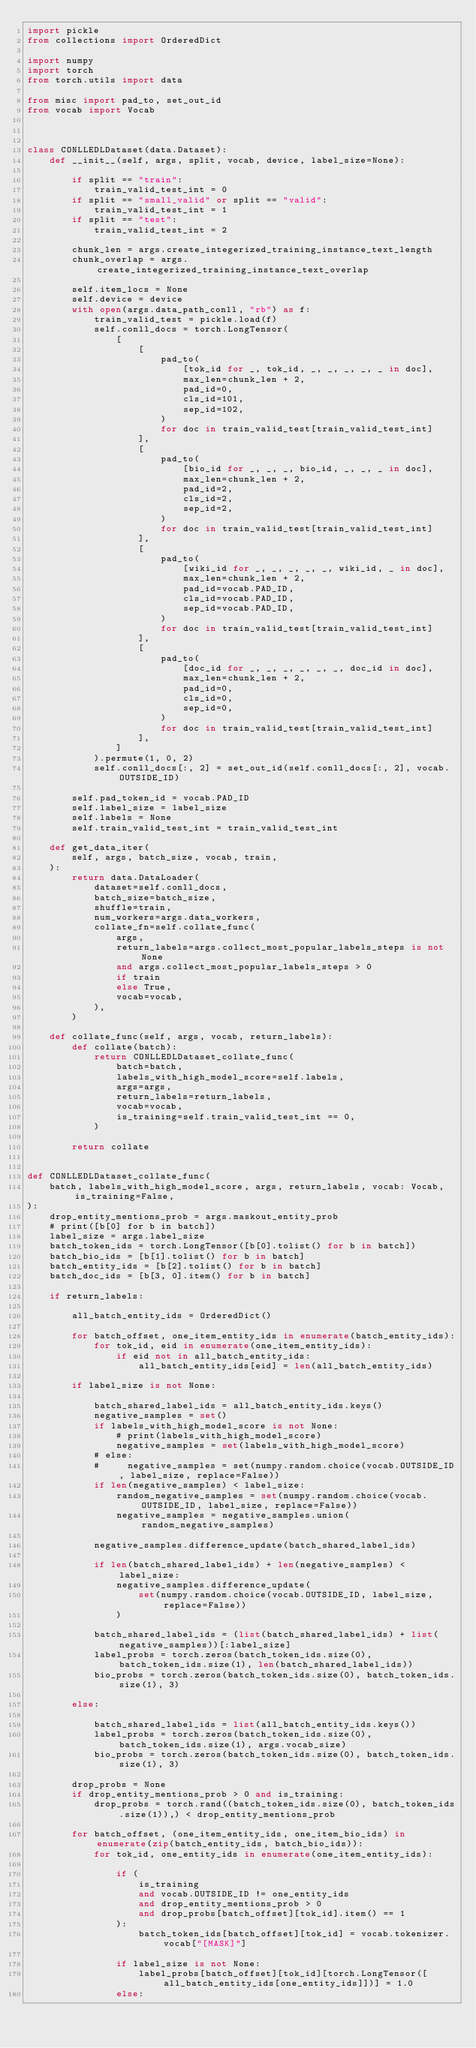<code> <loc_0><loc_0><loc_500><loc_500><_Python_>import pickle
from collections import OrderedDict

import numpy
import torch
from torch.utils import data

from misc import pad_to, set_out_id
from vocab import Vocab



class CONLLEDLDataset(data.Dataset):
    def __init__(self, args, split, vocab, device, label_size=None):

        if split == "train":
            train_valid_test_int = 0
        if split == "small_valid" or split == "valid":
            train_valid_test_int = 1
        if split == "test":
            train_valid_test_int = 2

        chunk_len = args.create_integerized_training_instance_text_length
        chunk_overlap = args.create_integerized_training_instance_text_overlap

        self.item_locs = None
        self.device = device
        with open(args.data_path_conll, "rb") as f:
            train_valid_test = pickle.load(f)
            self.conll_docs = torch.LongTensor(
                [
                    [
                        pad_to(
                            [tok_id for _, tok_id, _, _, _, _, _ in doc],
                            max_len=chunk_len + 2,
                            pad_id=0,
                            cls_id=101,
                            sep_id=102,
                        )
                        for doc in train_valid_test[train_valid_test_int]
                    ],
                    [
                        pad_to(
                            [bio_id for _, _, _, bio_id, _, _, _ in doc],
                            max_len=chunk_len + 2,
                            pad_id=2,
                            cls_id=2,
                            sep_id=2,
                        )
                        for doc in train_valid_test[train_valid_test_int]
                    ],
                    [
                        pad_to(
                            [wiki_id for _, _, _, _, _, wiki_id, _ in doc],
                            max_len=chunk_len + 2,
                            pad_id=vocab.PAD_ID,
                            cls_id=vocab.PAD_ID,
                            sep_id=vocab.PAD_ID,
                        )
                        for doc in train_valid_test[train_valid_test_int]
                    ],
                    [
                        pad_to(
                            [doc_id for _, _, _, _, _, _, doc_id in doc],
                            max_len=chunk_len + 2,
                            pad_id=0,
                            cls_id=0,
                            sep_id=0,
                        )
                        for doc in train_valid_test[train_valid_test_int]
                    ],
                ]
            ).permute(1, 0, 2)
            self.conll_docs[:, 2] = set_out_id(self.conll_docs[:, 2], vocab.OUTSIDE_ID)

        self.pad_token_id = vocab.PAD_ID
        self.label_size = label_size
        self.labels = None
        self.train_valid_test_int = train_valid_test_int

    def get_data_iter(
        self, args, batch_size, vocab, train,
    ):
        return data.DataLoader(
            dataset=self.conll_docs,
            batch_size=batch_size,
            shuffle=train,
            num_workers=args.data_workers,
            collate_fn=self.collate_func(
                args,
                return_labels=args.collect_most_popular_labels_steps is not None
                and args.collect_most_popular_labels_steps > 0
                if train
                else True,
                vocab=vocab,
            ),
        )

    def collate_func(self, args, vocab, return_labels):
        def collate(batch):
            return CONLLEDLDataset_collate_func(
                batch=batch,
                labels_with_high_model_score=self.labels,
                args=args,
                return_labels=return_labels,
                vocab=vocab,
                is_training=self.train_valid_test_int == 0,
            )

        return collate


def CONLLEDLDataset_collate_func(
    batch, labels_with_high_model_score, args, return_labels, vocab: Vocab, is_training=False,
):
    drop_entity_mentions_prob = args.maskout_entity_prob
    # print([b[0] for b in batch])
    label_size = args.label_size
    batch_token_ids = torch.LongTensor([b[0].tolist() for b in batch])
    batch_bio_ids = [b[1].tolist() for b in batch]
    batch_entity_ids = [b[2].tolist() for b in batch]
    batch_doc_ids = [b[3, 0].item() for b in batch]

    if return_labels:

        all_batch_entity_ids = OrderedDict()

        for batch_offset, one_item_entity_ids in enumerate(batch_entity_ids):
            for tok_id, eid in enumerate(one_item_entity_ids):
                if eid not in all_batch_entity_ids:
                    all_batch_entity_ids[eid] = len(all_batch_entity_ids)

        if label_size is not None:

            batch_shared_label_ids = all_batch_entity_ids.keys()
            negative_samples = set()
            if labels_with_high_model_score is not None:
                # print(labels_with_high_model_score)
                negative_samples = set(labels_with_high_model_score)
            # else:
            #     negative_samples = set(numpy.random.choice(vocab.OUTSIDE_ID, label_size, replace=False))
            if len(negative_samples) < label_size:
                random_negative_samples = set(numpy.random.choice(vocab.OUTSIDE_ID, label_size, replace=False))
                negative_samples = negative_samples.union(random_negative_samples)

            negative_samples.difference_update(batch_shared_label_ids)

            if len(batch_shared_label_ids) + len(negative_samples) < label_size:
                negative_samples.difference_update(
                    set(numpy.random.choice(vocab.OUTSIDE_ID, label_size, replace=False))
                )

            batch_shared_label_ids = (list(batch_shared_label_ids) + list(negative_samples))[:label_size]
            label_probs = torch.zeros(batch_token_ids.size(0), batch_token_ids.size(1), len(batch_shared_label_ids))
            bio_probs = torch.zeros(batch_token_ids.size(0), batch_token_ids.size(1), 3)

        else:

            batch_shared_label_ids = list(all_batch_entity_ids.keys())
            label_probs = torch.zeros(batch_token_ids.size(0), batch_token_ids.size(1), args.vocab_size)
            bio_probs = torch.zeros(batch_token_ids.size(0), batch_token_ids.size(1), 3)

        drop_probs = None
        if drop_entity_mentions_prob > 0 and is_training:
            drop_probs = torch.rand((batch_token_ids.size(0), batch_token_ids.size(1)),) < drop_entity_mentions_prob

        for batch_offset, (one_item_entity_ids, one_item_bio_ids) in enumerate(zip(batch_entity_ids, batch_bio_ids)):
            for tok_id, one_entity_ids in enumerate(one_item_entity_ids):

                if (
                    is_training
                    and vocab.OUTSIDE_ID != one_entity_ids
                    and drop_entity_mentions_prob > 0
                    and drop_probs[batch_offset][tok_id].item() == 1
                ):
                    batch_token_ids[batch_offset][tok_id] = vocab.tokenizer.vocab["[MASK]"]

                if label_size is not None:
                    label_probs[batch_offset][tok_id][torch.LongTensor([all_batch_entity_ids[one_entity_ids]])] = 1.0
                else:</code> 